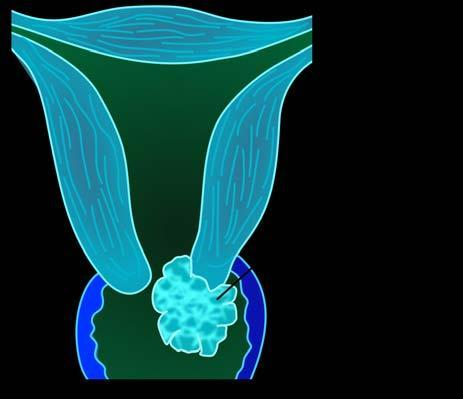does gross photograph on right show replacement of the cervix by irregular greywhite friable growth extending into cervical canal as well as distally into attached vaginal cuff?
Answer the question using a single word or phrase. Yes 